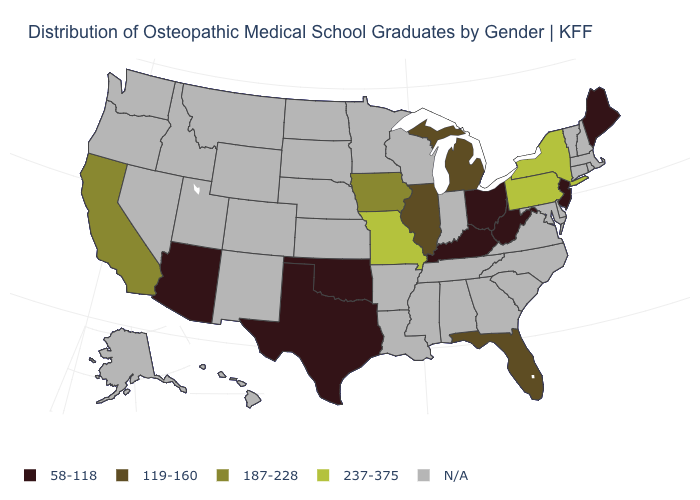Among the states that border Connecticut , which have the highest value?
Answer briefly. New York. What is the value of Maine?
Write a very short answer. 58-118. What is the value of Idaho?
Concise answer only. N/A. Name the states that have a value in the range 58-118?
Answer briefly. Arizona, Kentucky, Maine, New Jersey, Ohio, Oklahoma, Texas, West Virginia. What is the lowest value in states that border Nevada?
Write a very short answer. 58-118. Name the states that have a value in the range 58-118?
Be succinct. Arizona, Kentucky, Maine, New Jersey, Ohio, Oklahoma, Texas, West Virginia. What is the value of Colorado?
Write a very short answer. N/A. What is the highest value in states that border Georgia?
Give a very brief answer. 119-160. What is the value of Virginia?
Be succinct. N/A. Does the map have missing data?
Keep it brief. Yes. What is the highest value in states that border New Jersey?
Write a very short answer. 237-375. What is the value of Georgia?
Short answer required. N/A. 